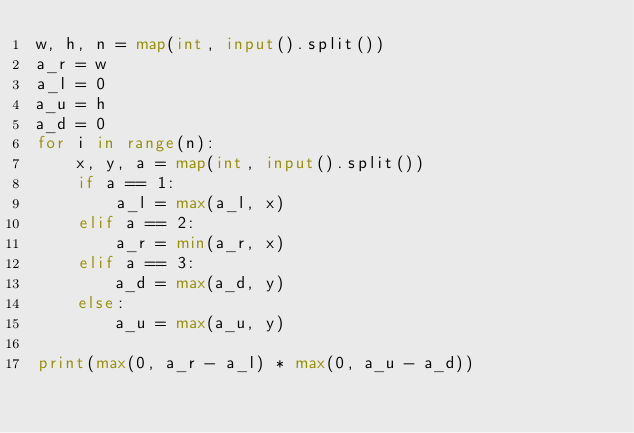Convert code to text. <code><loc_0><loc_0><loc_500><loc_500><_Python_>w, h, n = map(int, input().split())
a_r = w
a_l = 0
a_u = h
a_d = 0
for i in range(n):
    x, y, a = map(int, input().split())
    if a == 1:
        a_l = max(a_l, x)
    elif a == 2:
        a_r = min(a_r, x)
    elif a == 3:
        a_d = max(a_d, y)
    else:
        a_u = max(a_u, y)

print(max(0, a_r - a_l) * max(0, a_u - a_d))

</code> 